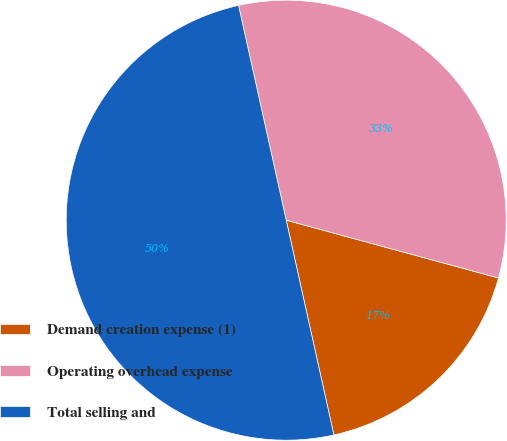Convert chart. <chart><loc_0><loc_0><loc_500><loc_500><pie_chart><fcel>Demand creation expense (1)<fcel>Operating overhead expense<fcel>Total selling and<nl><fcel>17.29%<fcel>32.71%<fcel>50.0%<nl></chart> 